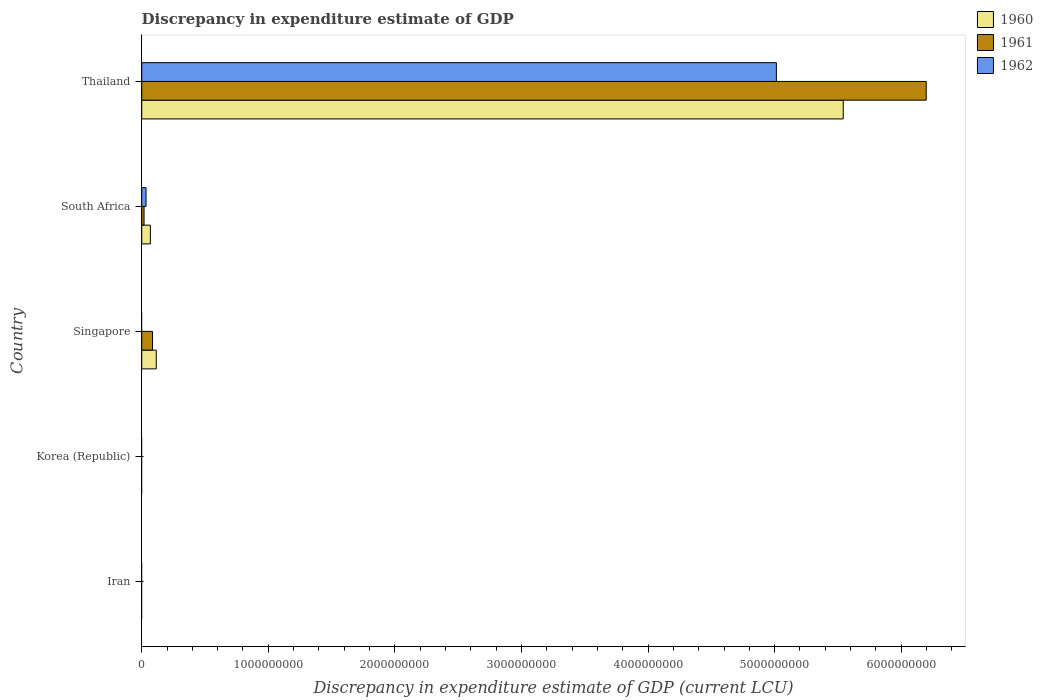How many different coloured bars are there?
Provide a short and direct response. 3. What is the label of the 4th group of bars from the top?
Your response must be concise. Korea (Republic). What is the discrepancy in expenditure estimate of GDP in 1962 in South Africa?
Ensure brevity in your answer.  3.40e+07. Across all countries, what is the maximum discrepancy in expenditure estimate of GDP in 1961?
Provide a succinct answer. 6.20e+09. In which country was the discrepancy in expenditure estimate of GDP in 1962 maximum?
Offer a terse response. Thailand. What is the total discrepancy in expenditure estimate of GDP in 1960 in the graph?
Provide a succinct answer. 5.72e+09. What is the difference between the discrepancy in expenditure estimate of GDP in 1960 in South Africa and that in Thailand?
Your response must be concise. -5.47e+09. What is the average discrepancy in expenditure estimate of GDP in 1962 per country?
Give a very brief answer. 1.01e+09. What is the difference between the discrepancy in expenditure estimate of GDP in 1962 and discrepancy in expenditure estimate of GDP in 1960 in Thailand?
Give a very brief answer. -5.28e+08. In how many countries, is the discrepancy in expenditure estimate of GDP in 1962 greater than 2000000000 LCU?
Give a very brief answer. 1. What is the ratio of the discrepancy in expenditure estimate of GDP in 1960 in Singapore to that in Thailand?
Ensure brevity in your answer.  0.02. Is the discrepancy in expenditure estimate of GDP in 1960 in Singapore less than that in Thailand?
Ensure brevity in your answer.  Yes. What is the difference between the highest and the second highest discrepancy in expenditure estimate of GDP in 1960?
Your answer should be very brief. 5.43e+09. What is the difference between the highest and the lowest discrepancy in expenditure estimate of GDP in 1962?
Offer a very short reply. 5.01e+09. How many bars are there?
Give a very brief answer. 8. How many countries are there in the graph?
Provide a succinct answer. 5. What is the difference between two consecutive major ticks on the X-axis?
Your response must be concise. 1.00e+09. Are the values on the major ticks of X-axis written in scientific E-notation?
Your response must be concise. No. Does the graph contain any zero values?
Your answer should be compact. Yes. Where does the legend appear in the graph?
Offer a very short reply. Top right. What is the title of the graph?
Provide a succinct answer. Discrepancy in expenditure estimate of GDP. Does "1988" appear as one of the legend labels in the graph?
Ensure brevity in your answer.  No. What is the label or title of the X-axis?
Ensure brevity in your answer.  Discrepancy in expenditure estimate of GDP (current LCU). What is the Discrepancy in expenditure estimate of GDP (current LCU) of 1961 in Iran?
Keep it short and to the point. 0. What is the Discrepancy in expenditure estimate of GDP (current LCU) of 1960 in Korea (Republic)?
Offer a terse response. 0. What is the Discrepancy in expenditure estimate of GDP (current LCU) in 1961 in Korea (Republic)?
Provide a short and direct response. 0. What is the Discrepancy in expenditure estimate of GDP (current LCU) of 1960 in Singapore?
Ensure brevity in your answer.  1.15e+08. What is the Discrepancy in expenditure estimate of GDP (current LCU) of 1961 in Singapore?
Keep it short and to the point. 8.53e+07. What is the Discrepancy in expenditure estimate of GDP (current LCU) in 1960 in South Africa?
Offer a terse response. 6.83e+07. What is the Discrepancy in expenditure estimate of GDP (current LCU) of 1961 in South Africa?
Your response must be concise. 1.84e+07. What is the Discrepancy in expenditure estimate of GDP (current LCU) of 1962 in South Africa?
Your answer should be compact. 3.40e+07. What is the Discrepancy in expenditure estimate of GDP (current LCU) in 1960 in Thailand?
Give a very brief answer. 5.54e+09. What is the Discrepancy in expenditure estimate of GDP (current LCU) of 1961 in Thailand?
Make the answer very short. 6.20e+09. What is the Discrepancy in expenditure estimate of GDP (current LCU) in 1962 in Thailand?
Ensure brevity in your answer.  5.01e+09. Across all countries, what is the maximum Discrepancy in expenditure estimate of GDP (current LCU) in 1960?
Provide a short and direct response. 5.54e+09. Across all countries, what is the maximum Discrepancy in expenditure estimate of GDP (current LCU) of 1961?
Keep it short and to the point. 6.20e+09. Across all countries, what is the maximum Discrepancy in expenditure estimate of GDP (current LCU) in 1962?
Keep it short and to the point. 5.01e+09. Across all countries, what is the minimum Discrepancy in expenditure estimate of GDP (current LCU) of 1960?
Your response must be concise. 0. What is the total Discrepancy in expenditure estimate of GDP (current LCU) of 1960 in the graph?
Give a very brief answer. 5.72e+09. What is the total Discrepancy in expenditure estimate of GDP (current LCU) in 1961 in the graph?
Ensure brevity in your answer.  6.30e+09. What is the total Discrepancy in expenditure estimate of GDP (current LCU) in 1962 in the graph?
Provide a short and direct response. 5.05e+09. What is the difference between the Discrepancy in expenditure estimate of GDP (current LCU) of 1960 in Singapore and that in South Africa?
Make the answer very short. 4.66e+07. What is the difference between the Discrepancy in expenditure estimate of GDP (current LCU) in 1961 in Singapore and that in South Africa?
Keep it short and to the point. 6.69e+07. What is the difference between the Discrepancy in expenditure estimate of GDP (current LCU) in 1960 in Singapore and that in Thailand?
Your answer should be very brief. -5.43e+09. What is the difference between the Discrepancy in expenditure estimate of GDP (current LCU) in 1961 in Singapore and that in Thailand?
Offer a very short reply. -6.11e+09. What is the difference between the Discrepancy in expenditure estimate of GDP (current LCU) of 1960 in South Africa and that in Thailand?
Offer a terse response. -5.47e+09. What is the difference between the Discrepancy in expenditure estimate of GDP (current LCU) of 1961 in South Africa and that in Thailand?
Your answer should be very brief. -6.18e+09. What is the difference between the Discrepancy in expenditure estimate of GDP (current LCU) in 1962 in South Africa and that in Thailand?
Your answer should be very brief. -4.98e+09. What is the difference between the Discrepancy in expenditure estimate of GDP (current LCU) of 1960 in Singapore and the Discrepancy in expenditure estimate of GDP (current LCU) of 1961 in South Africa?
Make the answer very short. 9.65e+07. What is the difference between the Discrepancy in expenditure estimate of GDP (current LCU) of 1960 in Singapore and the Discrepancy in expenditure estimate of GDP (current LCU) of 1962 in South Africa?
Ensure brevity in your answer.  8.09e+07. What is the difference between the Discrepancy in expenditure estimate of GDP (current LCU) in 1961 in Singapore and the Discrepancy in expenditure estimate of GDP (current LCU) in 1962 in South Africa?
Your response must be concise. 5.13e+07. What is the difference between the Discrepancy in expenditure estimate of GDP (current LCU) of 1960 in Singapore and the Discrepancy in expenditure estimate of GDP (current LCU) of 1961 in Thailand?
Your answer should be compact. -6.08e+09. What is the difference between the Discrepancy in expenditure estimate of GDP (current LCU) in 1960 in Singapore and the Discrepancy in expenditure estimate of GDP (current LCU) in 1962 in Thailand?
Provide a short and direct response. -4.90e+09. What is the difference between the Discrepancy in expenditure estimate of GDP (current LCU) in 1961 in Singapore and the Discrepancy in expenditure estimate of GDP (current LCU) in 1962 in Thailand?
Provide a succinct answer. -4.93e+09. What is the difference between the Discrepancy in expenditure estimate of GDP (current LCU) in 1960 in South Africa and the Discrepancy in expenditure estimate of GDP (current LCU) in 1961 in Thailand?
Ensure brevity in your answer.  -6.13e+09. What is the difference between the Discrepancy in expenditure estimate of GDP (current LCU) of 1960 in South Africa and the Discrepancy in expenditure estimate of GDP (current LCU) of 1962 in Thailand?
Your answer should be very brief. -4.95e+09. What is the difference between the Discrepancy in expenditure estimate of GDP (current LCU) in 1961 in South Africa and the Discrepancy in expenditure estimate of GDP (current LCU) in 1962 in Thailand?
Keep it short and to the point. -5.00e+09. What is the average Discrepancy in expenditure estimate of GDP (current LCU) in 1960 per country?
Ensure brevity in your answer.  1.14e+09. What is the average Discrepancy in expenditure estimate of GDP (current LCU) of 1961 per country?
Keep it short and to the point. 1.26e+09. What is the average Discrepancy in expenditure estimate of GDP (current LCU) in 1962 per country?
Provide a short and direct response. 1.01e+09. What is the difference between the Discrepancy in expenditure estimate of GDP (current LCU) of 1960 and Discrepancy in expenditure estimate of GDP (current LCU) of 1961 in Singapore?
Provide a succinct answer. 2.96e+07. What is the difference between the Discrepancy in expenditure estimate of GDP (current LCU) in 1960 and Discrepancy in expenditure estimate of GDP (current LCU) in 1961 in South Africa?
Provide a succinct answer. 4.99e+07. What is the difference between the Discrepancy in expenditure estimate of GDP (current LCU) in 1960 and Discrepancy in expenditure estimate of GDP (current LCU) in 1962 in South Africa?
Provide a short and direct response. 3.43e+07. What is the difference between the Discrepancy in expenditure estimate of GDP (current LCU) in 1961 and Discrepancy in expenditure estimate of GDP (current LCU) in 1962 in South Africa?
Offer a very short reply. -1.56e+07. What is the difference between the Discrepancy in expenditure estimate of GDP (current LCU) in 1960 and Discrepancy in expenditure estimate of GDP (current LCU) in 1961 in Thailand?
Keep it short and to the point. -6.56e+08. What is the difference between the Discrepancy in expenditure estimate of GDP (current LCU) in 1960 and Discrepancy in expenditure estimate of GDP (current LCU) in 1962 in Thailand?
Your response must be concise. 5.28e+08. What is the difference between the Discrepancy in expenditure estimate of GDP (current LCU) of 1961 and Discrepancy in expenditure estimate of GDP (current LCU) of 1962 in Thailand?
Give a very brief answer. 1.18e+09. What is the ratio of the Discrepancy in expenditure estimate of GDP (current LCU) in 1960 in Singapore to that in South Africa?
Keep it short and to the point. 1.68. What is the ratio of the Discrepancy in expenditure estimate of GDP (current LCU) of 1961 in Singapore to that in South Africa?
Offer a very short reply. 4.64. What is the ratio of the Discrepancy in expenditure estimate of GDP (current LCU) in 1960 in Singapore to that in Thailand?
Give a very brief answer. 0.02. What is the ratio of the Discrepancy in expenditure estimate of GDP (current LCU) of 1961 in Singapore to that in Thailand?
Your response must be concise. 0.01. What is the ratio of the Discrepancy in expenditure estimate of GDP (current LCU) in 1960 in South Africa to that in Thailand?
Give a very brief answer. 0.01. What is the ratio of the Discrepancy in expenditure estimate of GDP (current LCU) of 1961 in South Africa to that in Thailand?
Make the answer very short. 0. What is the ratio of the Discrepancy in expenditure estimate of GDP (current LCU) in 1962 in South Africa to that in Thailand?
Your answer should be very brief. 0.01. What is the difference between the highest and the second highest Discrepancy in expenditure estimate of GDP (current LCU) of 1960?
Provide a short and direct response. 5.43e+09. What is the difference between the highest and the second highest Discrepancy in expenditure estimate of GDP (current LCU) in 1961?
Provide a succinct answer. 6.11e+09. What is the difference between the highest and the lowest Discrepancy in expenditure estimate of GDP (current LCU) in 1960?
Keep it short and to the point. 5.54e+09. What is the difference between the highest and the lowest Discrepancy in expenditure estimate of GDP (current LCU) in 1961?
Offer a terse response. 6.20e+09. What is the difference between the highest and the lowest Discrepancy in expenditure estimate of GDP (current LCU) in 1962?
Ensure brevity in your answer.  5.01e+09. 